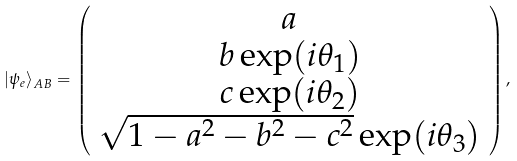<formula> <loc_0><loc_0><loc_500><loc_500>| \psi _ { e } \rangle _ { A B } = \left ( \begin{array} { c } a \\ b \exp ( i \theta _ { 1 } ) \\ c \exp ( i \theta _ { 2 } ) \\ \sqrt { 1 - a ^ { 2 } - b ^ { 2 } - c ^ { 2 } } \exp ( i \theta _ { 3 } ) \end{array} \right ) ,</formula> 